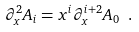Convert formula to latex. <formula><loc_0><loc_0><loc_500><loc_500>\partial ^ { 2 } _ { x } A _ { i } = x ^ { i } \partial ^ { i + 2 } _ { x } A _ { 0 } \ .</formula> 